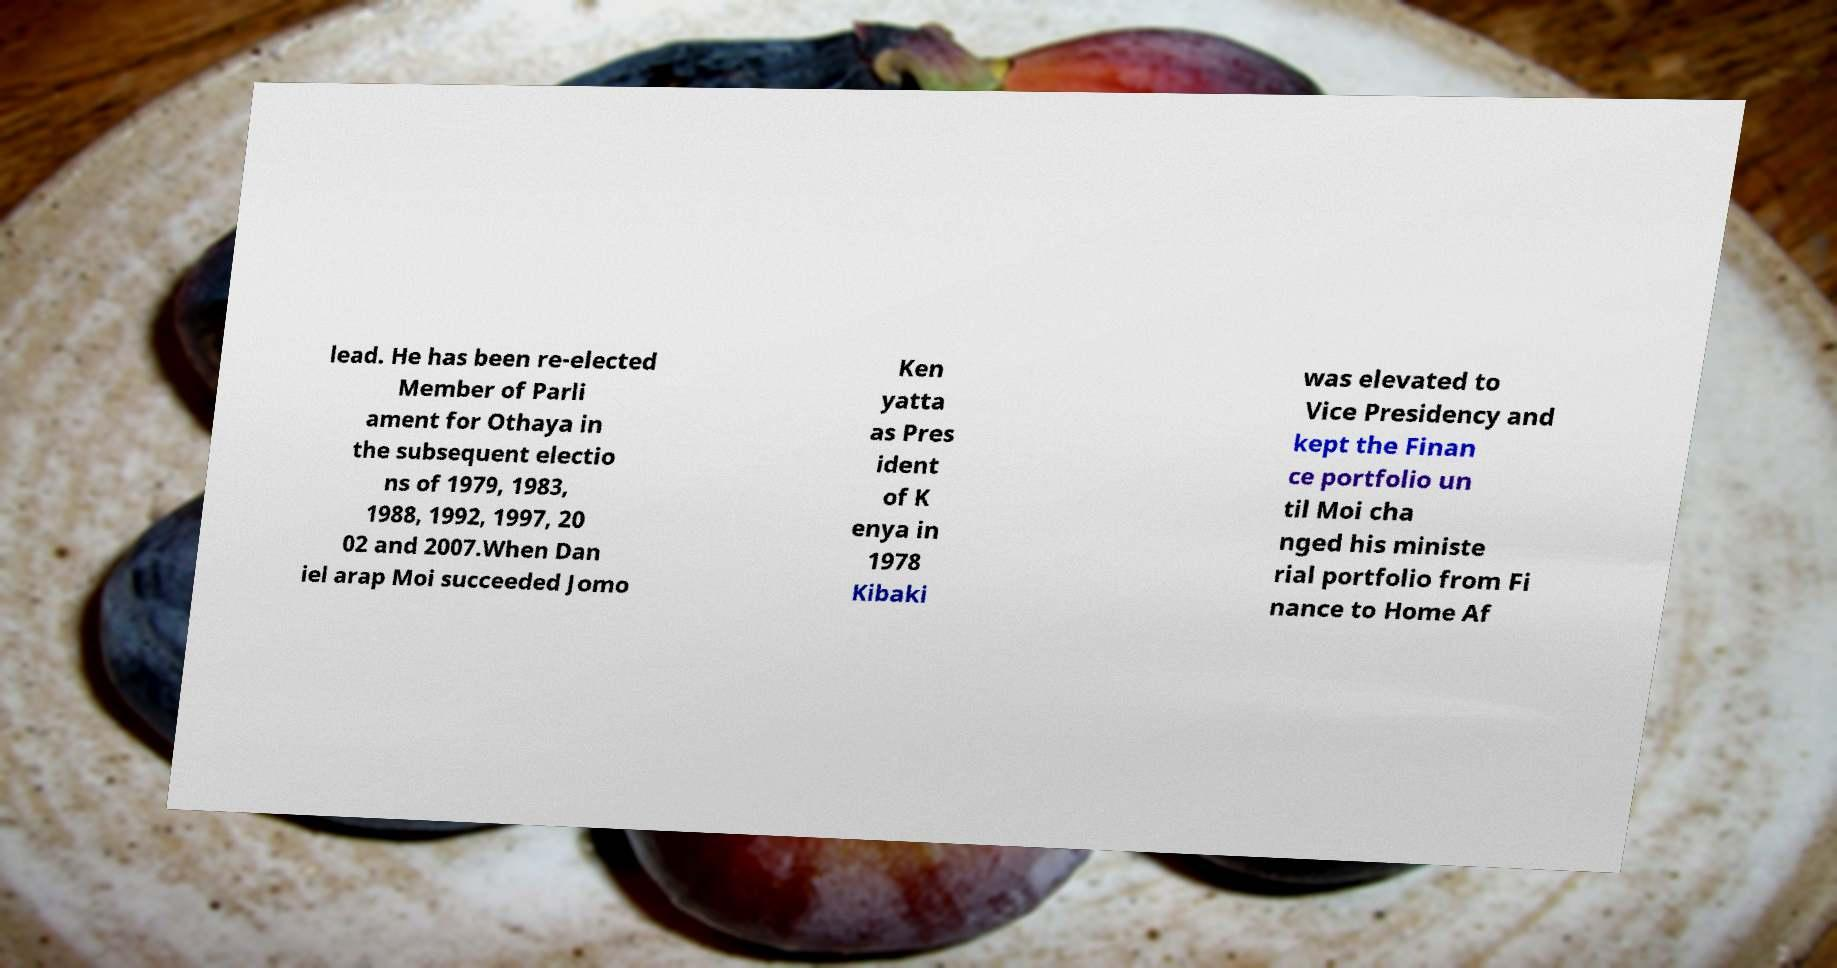Could you extract and type out the text from this image? lead. He has been re-elected Member of Parli ament for Othaya in the subsequent electio ns of 1979, 1983, 1988, 1992, 1997, 20 02 and 2007.When Dan iel arap Moi succeeded Jomo Ken yatta as Pres ident of K enya in 1978 Kibaki was elevated to Vice Presidency and kept the Finan ce portfolio un til Moi cha nged his ministe rial portfolio from Fi nance to Home Af 